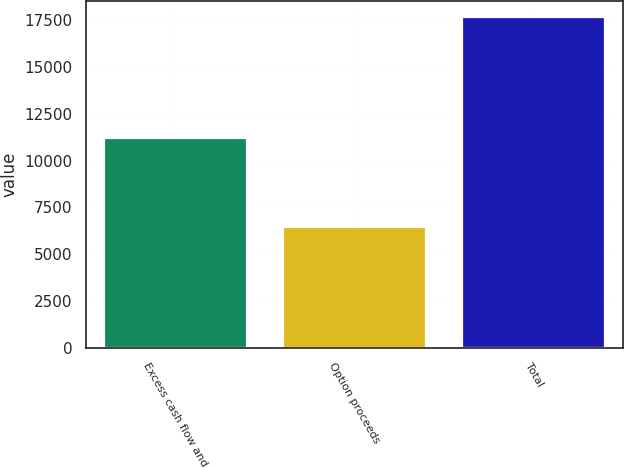Convert chart. <chart><loc_0><loc_0><loc_500><loc_500><bar_chart><fcel>Excess cash flow and<fcel>Option proceeds<fcel>Total<nl><fcel>11219<fcel>6438<fcel>17657<nl></chart> 